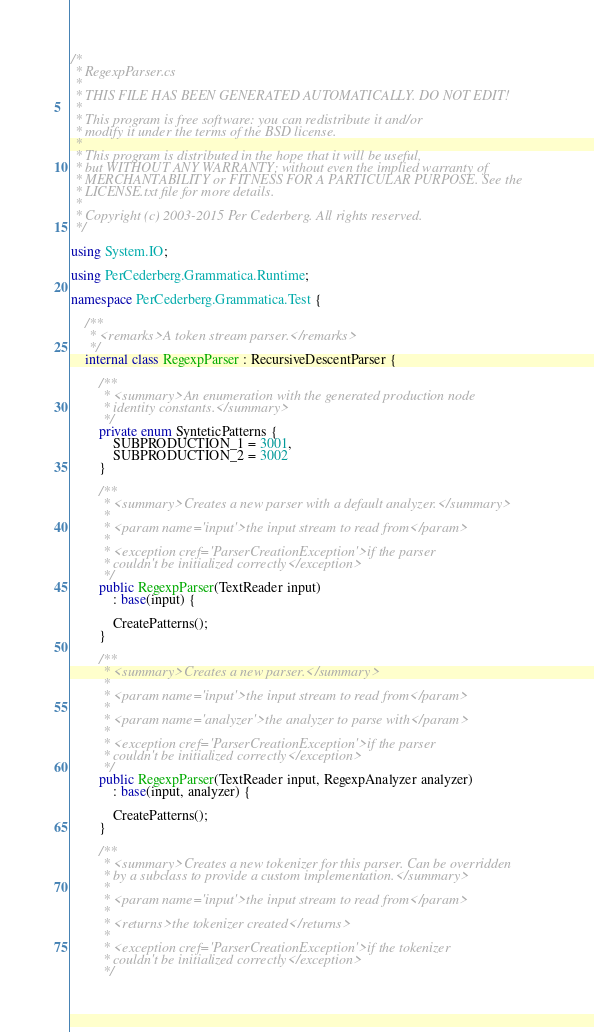Convert code to text. <code><loc_0><loc_0><loc_500><loc_500><_C#_>/*
 * RegexpParser.cs
 *
 * THIS FILE HAS BEEN GENERATED AUTOMATICALLY. DO NOT EDIT!
 *
 * This program is free software: you can redistribute it and/or
 * modify it under the terms of the BSD license.
 *
 * This program is distributed in the hope that it will be useful,
 * but WITHOUT ANY WARRANTY; without even the implied warranty of
 * MERCHANTABILITY or FITNESS FOR A PARTICULAR PURPOSE. See the
 * LICENSE.txt file for more details.
 *
 * Copyright (c) 2003-2015 Per Cederberg. All rights reserved.
 */

using System.IO;

using PerCederberg.Grammatica.Runtime;

namespace PerCederberg.Grammatica.Test {

    /**
     * <remarks>A token stream parser.</remarks>
     */
    internal class RegexpParser : RecursiveDescentParser {

        /**
         * <summary>An enumeration with the generated production node
         * identity constants.</summary>
         */
        private enum SynteticPatterns {
            SUBPRODUCTION_1 = 3001,
            SUBPRODUCTION_2 = 3002
        }

        /**
         * <summary>Creates a new parser with a default analyzer.</summary>
         *
         * <param name='input'>the input stream to read from</param>
         *
         * <exception cref='ParserCreationException'>if the parser
         * couldn't be initialized correctly</exception>
         */
        public RegexpParser(TextReader input)
            : base(input) {

            CreatePatterns();
        }

        /**
         * <summary>Creates a new parser.</summary>
         *
         * <param name='input'>the input stream to read from</param>
         *
         * <param name='analyzer'>the analyzer to parse with</param>
         *
         * <exception cref='ParserCreationException'>if the parser
         * couldn't be initialized correctly</exception>
         */
        public RegexpParser(TextReader input, RegexpAnalyzer analyzer)
            : base(input, analyzer) {

            CreatePatterns();
        }

        /**
         * <summary>Creates a new tokenizer for this parser. Can be overridden
         * by a subclass to provide a custom implementation.</summary>
         *
         * <param name='input'>the input stream to read from</param>
         *
         * <returns>the tokenizer created</returns>
         *
         * <exception cref='ParserCreationException'>if the tokenizer
         * couldn't be initialized correctly</exception>
         */</code> 